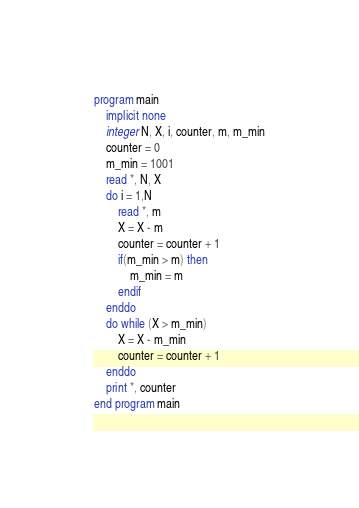<code> <loc_0><loc_0><loc_500><loc_500><_FORTRAN_>program main
    implicit none
    integer N, X, i, counter, m, m_min
    counter = 0
    m_min = 1001
    read *, N, X
    do i = 1,N
        read *, m
        X = X - m
        counter = counter + 1
        if(m_min > m) then
            m_min = m
        endif
    enddo
    do while (X > m_min)
        X = X - m_min
        counter = counter + 1
    enddo
    print *, counter
end program main
</code> 